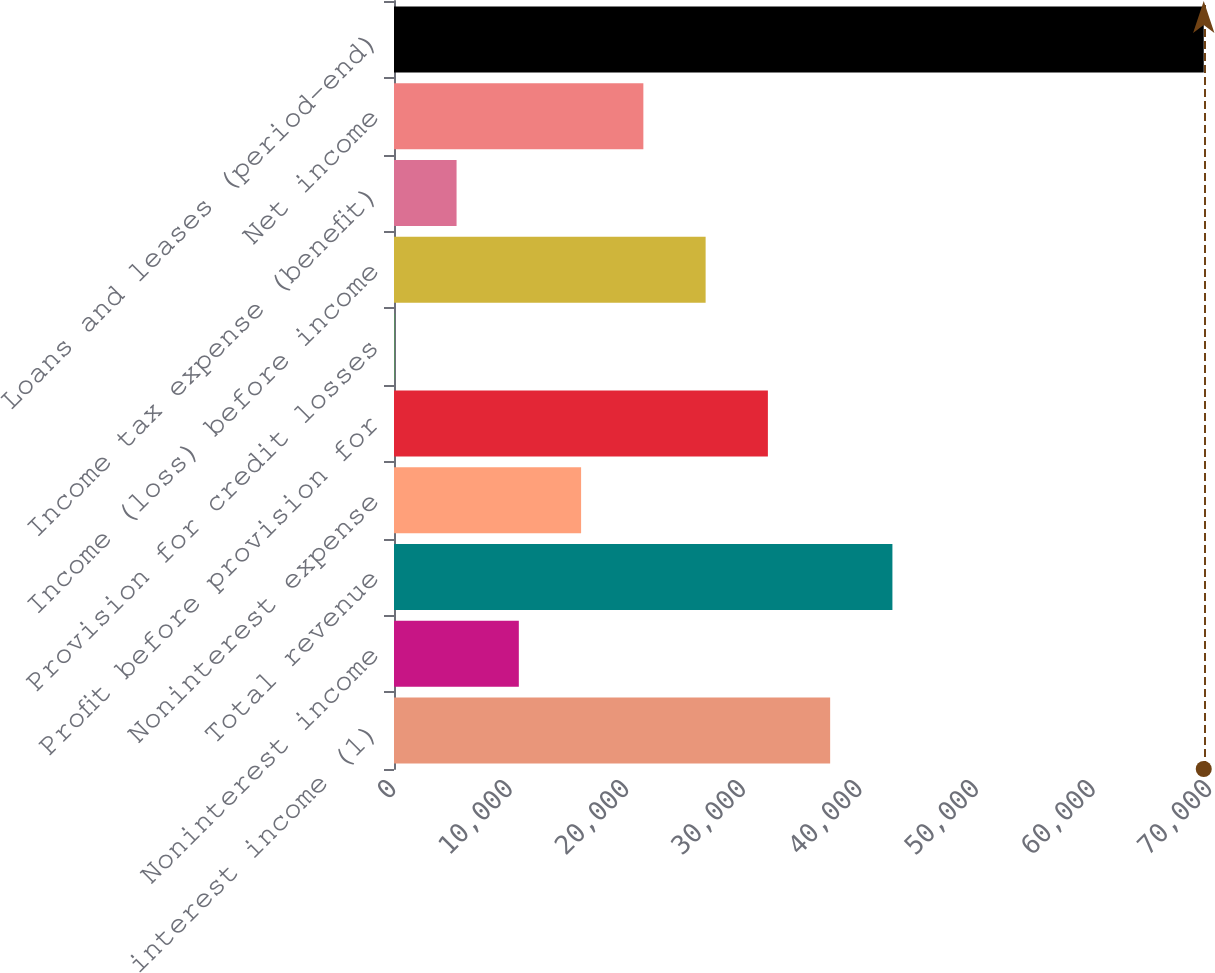<chart> <loc_0><loc_0><loc_500><loc_500><bar_chart><fcel>Net interest income (1)<fcel>Noninterest income<fcel>Total revenue<fcel>Noninterest expense<fcel>Profit before provision for<fcel>Provision for credit losses<fcel>Income (loss) before income<fcel>Income tax expense (benefit)<fcel>Net income<fcel>Loans and leases (period-end)<nl><fcel>37415.1<fcel>10708.6<fcel>42756.4<fcel>16049.9<fcel>32073.8<fcel>26<fcel>26732.5<fcel>5367.3<fcel>21391.2<fcel>69462.9<nl></chart> 